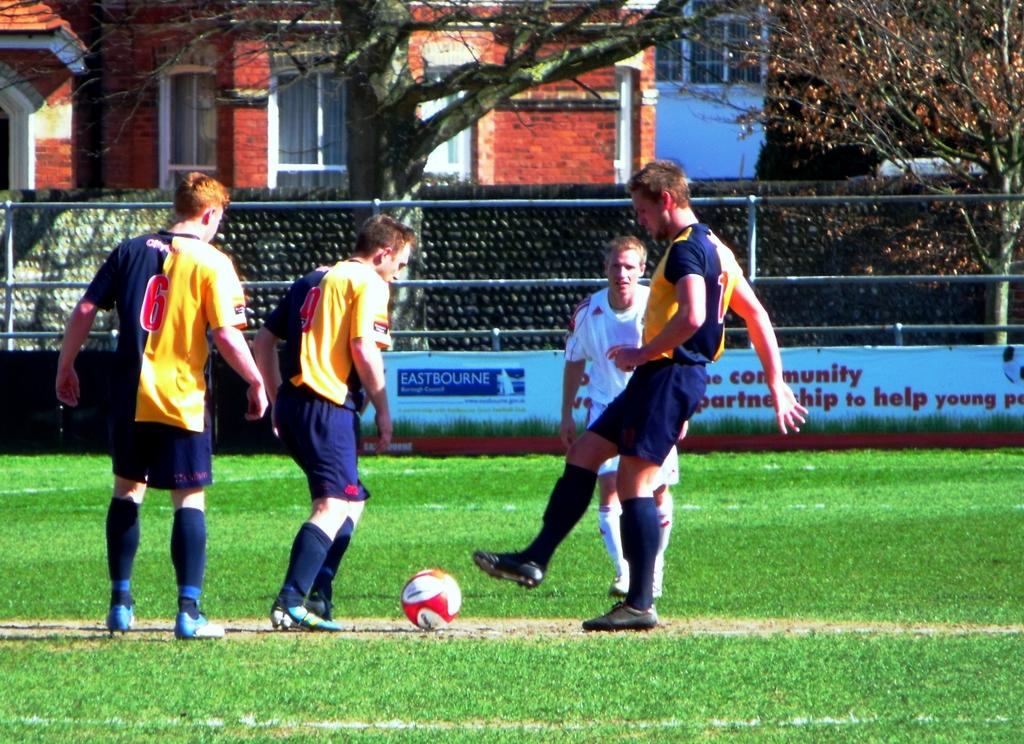<image>
Write a terse but informative summary of the picture. Soccer players playing in front of an ad which says "EASTBOURNE". 